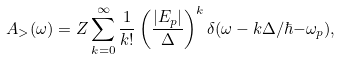Convert formula to latex. <formula><loc_0><loc_0><loc_500><loc_500>A _ { > } ( \omega ) = Z \sum _ { k = 0 } ^ { \infty } \frac { 1 } { k ! } \left ( \frac { | E _ { p } | } { \Delta } \right ) ^ { k } \delta ( \omega - k \Delta / \hbar { - } \omega _ { p } ) ,</formula> 